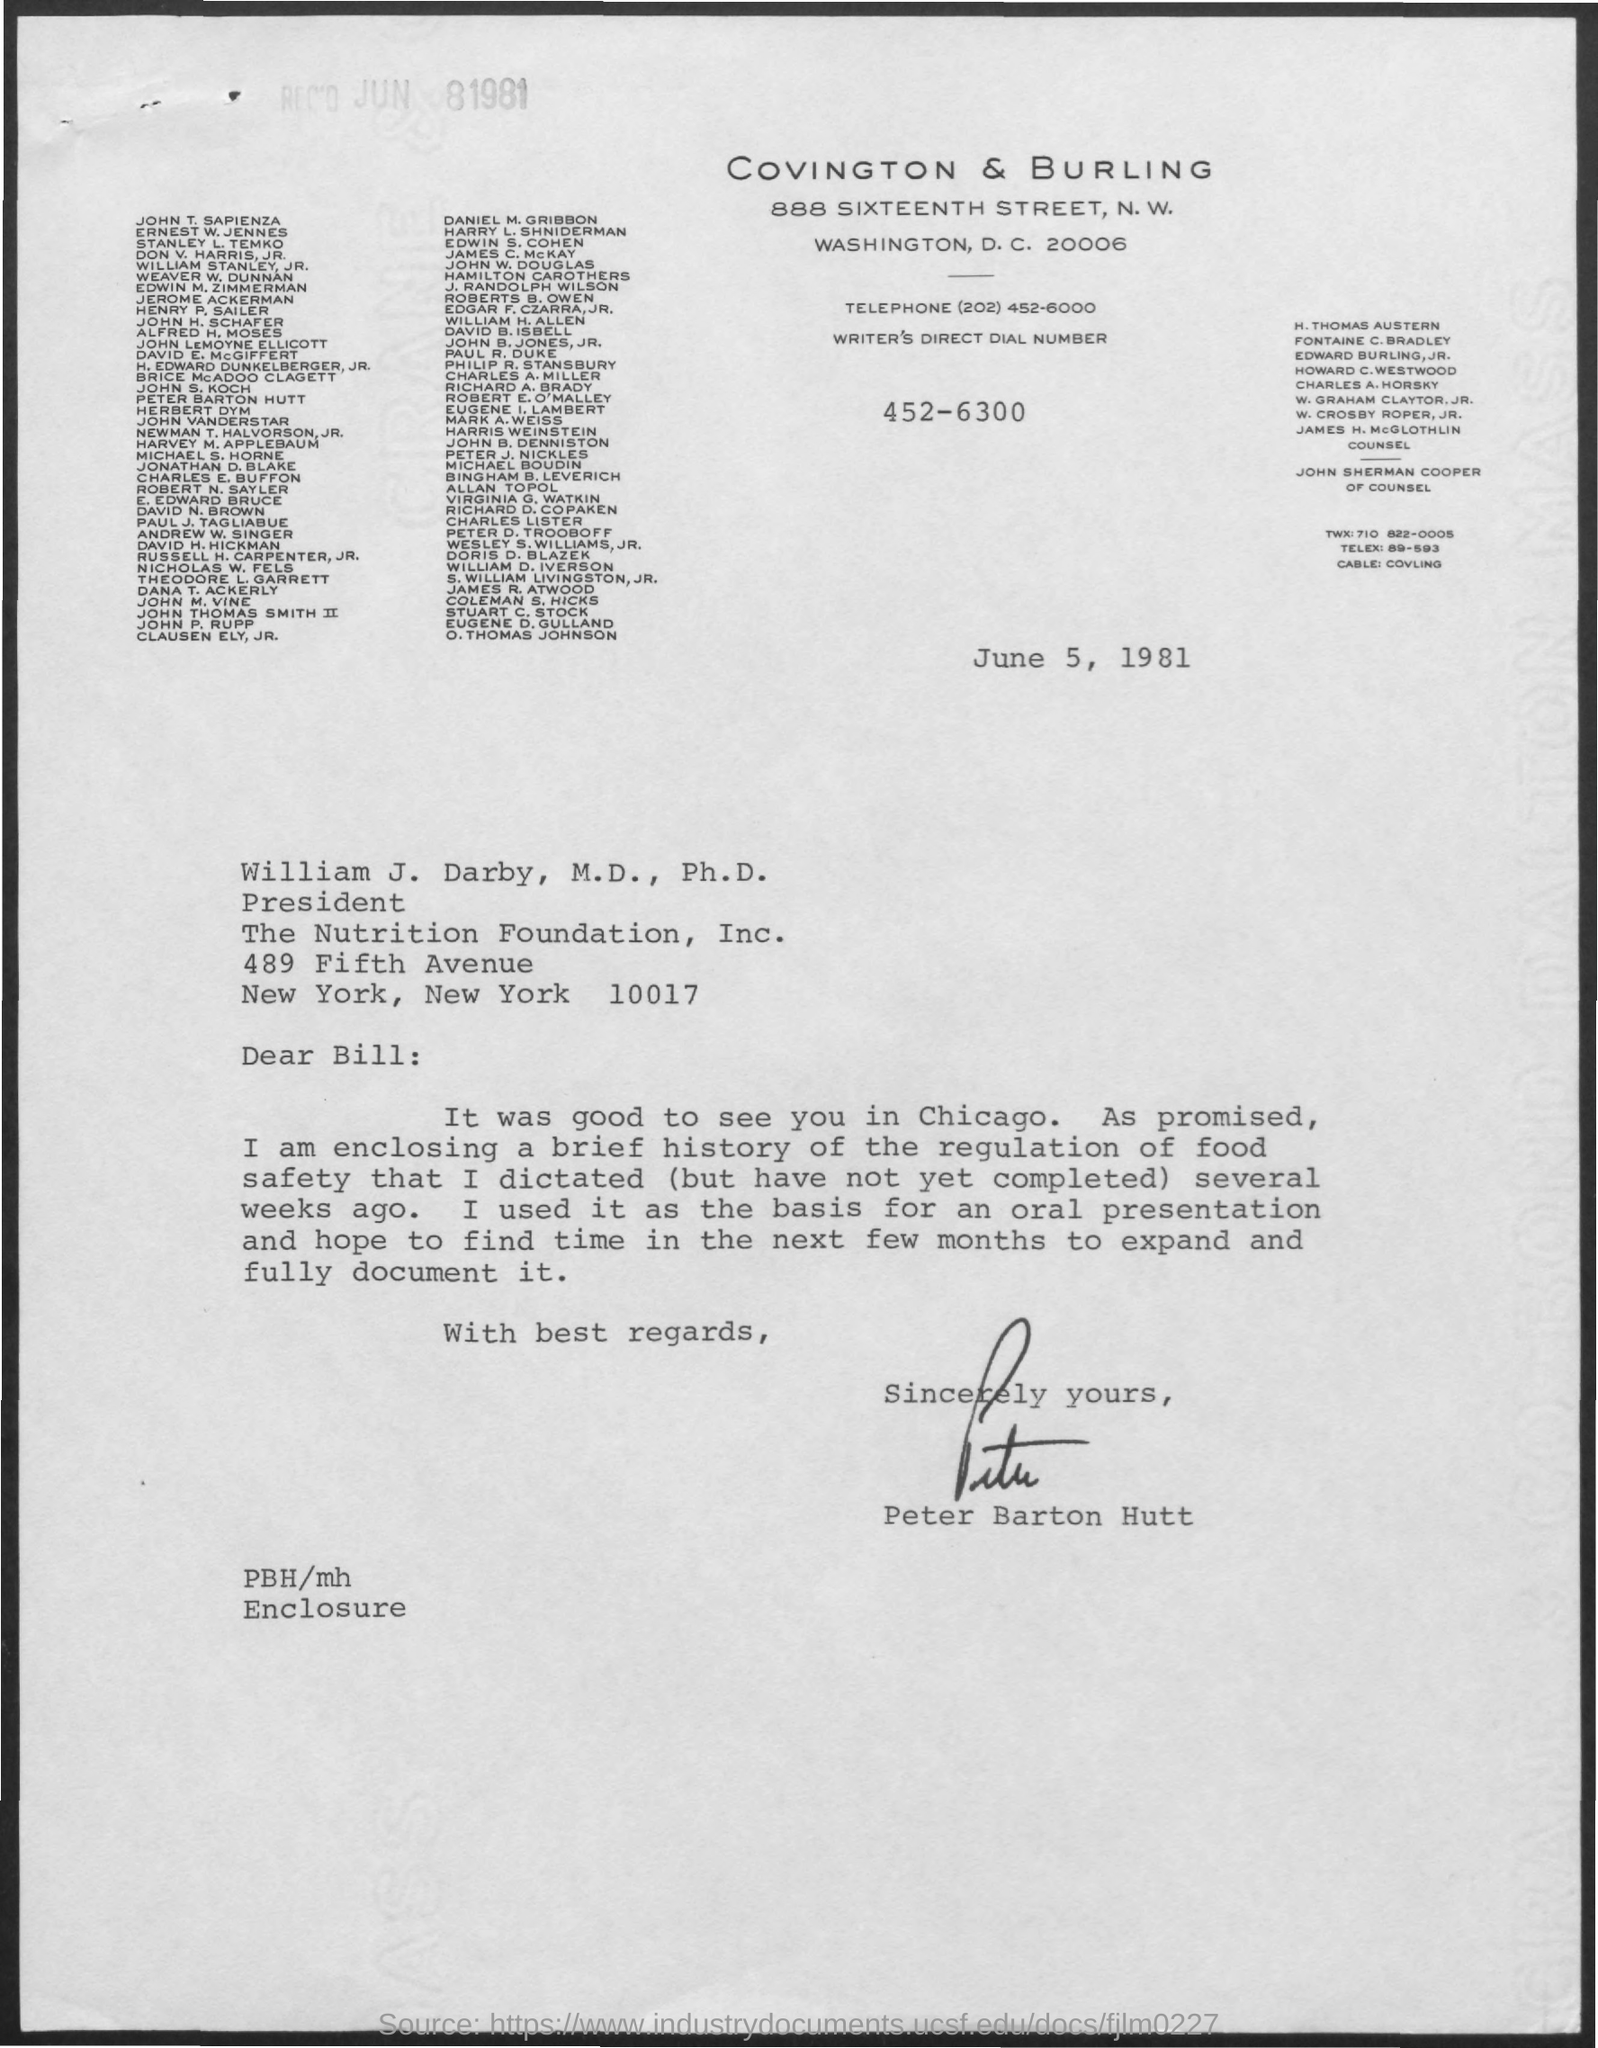Highlight a few significant elements in this photo. The date mentioned is June 5, 1981. The author of this letter is Peter Barton Hutt. 